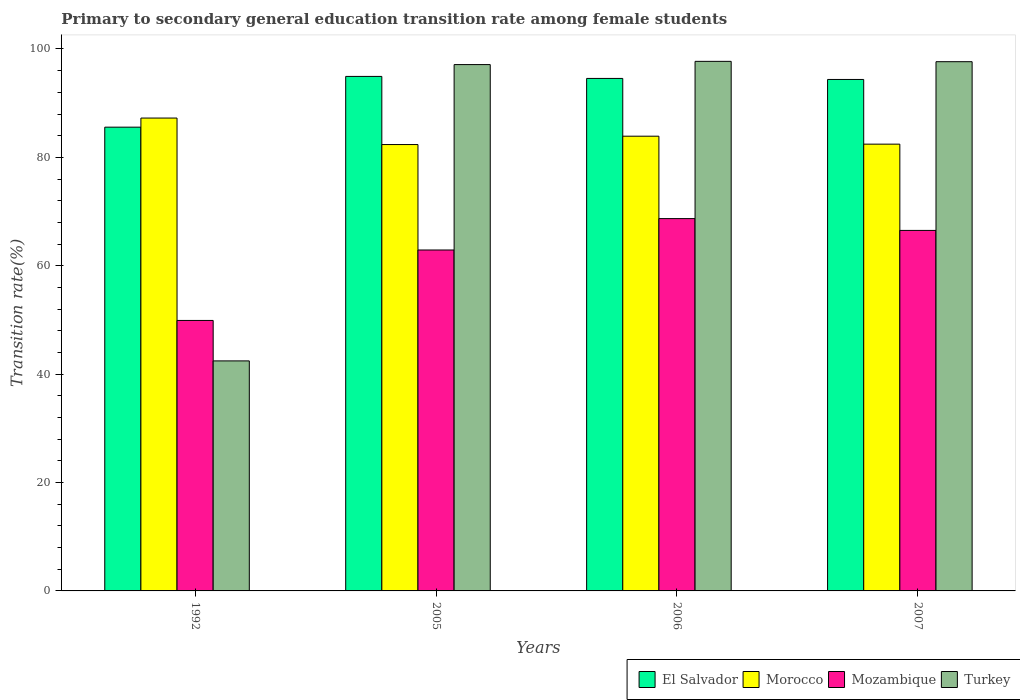How many different coloured bars are there?
Offer a very short reply. 4. How many groups of bars are there?
Offer a terse response. 4. Are the number of bars per tick equal to the number of legend labels?
Offer a terse response. Yes. How many bars are there on the 4th tick from the left?
Ensure brevity in your answer.  4. How many bars are there on the 1st tick from the right?
Your response must be concise. 4. What is the label of the 2nd group of bars from the left?
Provide a succinct answer. 2005. In how many cases, is the number of bars for a given year not equal to the number of legend labels?
Provide a short and direct response. 0. What is the transition rate in El Salvador in 2007?
Make the answer very short. 94.37. Across all years, what is the maximum transition rate in Mozambique?
Keep it short and to the point. 68.7. Across all years, what is the minimum transition rate in Mozambique?
Offer a terse response. 49.91. In which year was the transition rate in Mozambique maximum?
Offer a very short reply. 2006. What is the total transition rate in Turkey in the graph?
Make the answer very short. 334.93. What is the difference between the transition rate in El Salvador in 1992 and that in 2006?
Provide a succinct answer. -8.99. What is the difference between the transition rate in El Salvador in 2005 and the transition rate in Turkey in 2006?
Make the answer very short. -2.78. What is the average transition rate in Mozambique per year?
Provide a short and direct response. 62.01. In the year 1992, what is the difference between the transition rate in Mozambique and transition rate in El Salvador?
Make the answer very short. -35.66. What is the ratio of the transition rate in Morocco in 1992 to that in 2007?
Your response must be concise. 1.06. What is the difference between the highest and the second highest transition rate in Mozambique?
Provide a succinct answer. 2.18. What is the difference between the highest and the lowest transition rate in El Salvador?
Your answer should be very brief. 9.37. Is the sum of the transition rate in Turkey in 2005 and 2007 greater than the maximum transition rate in Morocco across all years?
Ensure brevity in your answer.  Yes. What does the 4th bar from the left in 2006 represents?
Provide a succinct answer. Turkey. What does the 2nd bar from the right in 2005 represents?
Offer a very short reply. Mozambique. How many bars are there?
Keep it short and to the point. 16. Are all the bars in the graph horizontal?
Provide a short and direct response. No. How many years are there in the graph?
Provide a short and direct response. 4. What is the difference between two consecutive major ticks on the Y-axis?
Provide a succinct answer. 20. Does the graph contain any zero values?
Make the answer very short. No. Where does the legend appear in the graph?
Provide a succinct answer. Bottom right. What is the title of the graph?
Provide a succinct answer. Primary to secondary general education transition rate among female students. What is the label or title of the X-axis?
Your response must be concise. Years. What is the label or title of the Y-axis?
Your response must be concise. Transition rate(%). What is the Transition rate(%) of El Salvador in 1992?
Ensure brevity in your answer.  85.57. What is the Transition rate(%) of Morocco in 1992?
Your answer should be compact. 87.25. What is the Transition rate(%) in Mozambique in 1992?
Give a very brief answer. 49.91. What is the Transition rate(%) in Turkey in 1992?
Make the answer very short. 42.44. What is the Transition rate(%) in El Salvador in 2005?
Give a very brief answer. 94.94. What is the Transition rate(%) of Morocco in 2005?
Your answer should be compact. 82.36. What is the Transition rate(%) in Mozambique in 2005?
Your response must be concise. 62.91. What is the Transition rate(%) in Turkey in 2005?
Offer a terse response. 97.12. What is the Transition rate(%) in El Salvador in 2006?
Offer a terse response. 94.56. What is the Transition rate(%) of Morocco in 2006?
Your response must be concise. 83.91. What is the Transition rate(%) in Mozambique in 2006?
Provide a succinct answer. 68.7. What is the Transition rate(%) in Turkey in 2006?
Your response must be concise. 97.72. What is the Transition rate(%) in El Salvador in 2007?
Your response must be concise. 94.37. What is the Transition rate(%) of Morocco in 2007?
Make the answer very short. 82.44. What is the Transition rate(%) in Mozambique in 2007?
Ensure brevity in your answer.  66.52. What is the Transition rate(%) in Turkey in 2007?
Your answer should be compact. 97.65. Across all years, what is the maximum Transition rate(%) in El Salvador?
Offer a terse response. 94.94. Across all years, what is the maximum Transition rate(%) in Morocco?
Ensure brevity in your answer.  87.25. Across all years, what is the maximum Transition rate(%) of Mozambique?
Provide a succinct answer. 68.7. Across all years, what is the maximum Transition rate(%) in Turkey?
Offer a terse response. 97.72. Across all years, what is the minimum Transition rate(%) of El Salvador?
Give a very brief answer. 85.57. Across all years, what is the minimum Transition rate(%) in Morocco?
Your response must be concise. 82.36. Across all years, what is the minimum Transition rate(%) of Mozambique?
Provide a short and direct response. 49.91. Across all years, what is the minimum Transition rate(%) of Turkey?
Keep it short and to the point. 42.44. What is the total Transition rate(%) in El Salvador in the graph?
Provide a succinct answer. 369.44. What is the total Transition rate(%) in Morocco in the graph?
Your response must be concise. 335.96. What is the total Transition rate(%) in Mozambique in the graph?
Offer a very short reply. 248.03. What is the total Transition rate(%) in Turkey in the graph?
Offer a terse response. 334.93. What is the difference between the Transition rate(%) in El Salvador in 1992 and that in 2005?
Provide a short and direct response. -9.37. What is the difference between the Transition rate(%) in Morocco in 1992 and that in 2005?
Offer a terse response. 4.89. What is the difference between the Transition rate(%) of Mozambique in 1992 and that in 2005?
Your response must be concise. -13. What is the difference between the Transition rate(%) in Turkey in 1992 and that in 2005?
Offer a terse response. -54.68. What is the difference between the Transition rate(%) of El Salvador in 1992 and that in 2006?
Your answer should be very brief. -8.99. What is the difference between the Transition rate(%) in Morocco in 1992 and that in 2006?
Make the answer very short. 3.35. What is the difference between the Transition rate(%) in Mozambique in 1992 and that in 2006?
Offer a terse response. -18.79. What is the difference between the Transition rate(%) in Turkey in 1992 and that in 2006?
Make the answer very short. -55.27. What is the difference between the Transition rate(%) of El Salvador in 1992 and that in 2007?
Your answer should be very brief. -8.8. What is the difference between the Transition rate(%) in Morocco in 1992 and that in 2007?
Offer a very short reply. 4.82. What is the difference between the Transition rate(%) in Mozambique in 1992 and that in 2007?
Offer a terse response. -16.61. What is the difference between the Transition rate(%) of Turkey in 1992 and that in 2007?
Your answer should be compact. -55.21. What is the difference between the Transition rate(%) in El Salvador in 2005 and that in 2006?
Make the answer very short. 0.37. What is the difference between the Transition rate(%) in Morocco in 2005 and that in 2006?
Ensure brevity in your answer.  -1.54. What is the difference between the Transition rate(%) of Mozambique in 2005 and that in 2006?
Offer a terse response. -5.79. What is the difference between the Transition rate(%) in Turkey in 2005 and that in 2006?
Provide a short and direct response. -0.6. What is the difference between the Transition rate(%) of El Salvador in 2005 and that in 2007?
Offer a terse response. 0.56. What is the difference between the Transition rate(%) in Morocco in 2005 and that in 2007?
Your response must be concise. -0.08. What is the difference between the Transition rate(%) in Mozambique in 2005 and that in 2007?
Keep it short and to the point. -3.61. What is the difference between the Transition rate(%) in Turkey in 2005 and that in 2007?
Ensure brevity in your answer.  -0.53. What is the difference between the Transition rate(%) of El Salvador in 2006 and that in 2007?
Provide a short and direct response. 0.19. What is the difference between the Transition rate(%) in Morocco in 2006 and that in 2007?
Ensure brevity in your answer.  1.47. What is the difference between the Transition rate(%) of Mozambique in 2006 and that in 2007?
Your answer should be compact. 2.18. What is the difference between the Transition rate(%) of Turkey in 2006 and that in 2007?
Give a very brief answer. 0.06. What is the difference between the Transition rate(%) in El Salvador in 1992 and the Transition rate(%) in Morocco in 2005?
Ensure brevity in your answer.  3.21. What is the difference between the Transition rate(%) in El Salvador in 1992 and the Transition rate(%) in Mozambique in 2005?
Ensure brevity in your answer.  22.66. What is the difference between the Transition rate(%) of El Salvador in 1992 and the Transition rate(%) of Turkey in 2005?
Ensure brevity in your answer.  -11.55. What is the difference between the Transition rate(%) of Morocco in 1992 and the Transition rate(%) of Mozambique in 2005?
Your answer should be very brief. 24.34. What is the difference between the Transition rate(%) of Morocco in 1992 and the Transition rate(%) of Turkey in 2005?
Your response must be concise. -9.87. What is the difference between the Transition rate(%) of Mozambique in 1992 and the Transition rate(%) of Turkey in 2005?
Provide a succinct answer. -47.21. What is the difference between the Transition rate(%) in El Salvador in 1992 and the Transition rate(%) in Morocco in 2006?
Keep it short and to the point. 1.66. What is the difference between the Transition rate(%) in El Salvador in 1992 and the Transition rate(%) in Mozambique in 2006?
Give a very brief answer. 16.87. What is the difference between the Transition rate(%) of El Salvador in 1992 and the Transition rate(%) of Turkey in 2006?
Keep it short and to the point. -12.14. What is the difference between the Transition rate(%) in Morocco in 1992 and the Transition rate(%) in Mozambique in 2006?
Provide a short and direct response. 18.55. What is the difference between the Transition rate(%) in Morocco in 1992 and the Transition rate(%) in Turkey in 2006?
Make the answer very short. -10.46. What is the difference between the Transition rate(%) of Mozambique in 1992 and the Transition rate(%) of Turkey in 2006?
Give a very brief answer. -47.81. What is the difference between the Transition rate(%) of El Salvador in 1992 and the Transition rate(%) of Morocco in 2007?
Offer a very short reply. 3.13. What is the difference between the Transition rate(%) of El Salvador in 1992 and the Transition rate(%) of Mozambique in 2007?
Keep it short and to the point. 19.05. What is the difference between the Transition rate(%) in El Salvador in 1992 and the Transition rate(%) in Turkey in 2007?
Offer a terse response. -12.08. What is the difference between the Transition rate(%) in Morocco in 1992 and the Transition rate(%) in Mozambique in 2007?
Ensure brevity in your answer.  20.73. What is the difference between the Transition rate(%) of Morocco in 1992 and the Transition rate(%) of Turkey in 2007?
Provide a succinct answer. -10.4. What is the difference between the Transition rate(%) of Mozambique in 1992 and the Transition rate(%) of Turkey in 2007?
Give a very brief answer. -47.74. What is the difference between the Transition rate(%) of El Salvador in 2005 and the Transition rate(%) of Morocco in 2006?
Make the answer very short. 11.03. What is the difference between the Transition rate(%) in El Salvador in 2005 and the Transition rate(%) in Mozambique in 2006?
Keep it short and to the point. 26.24. What is the difference between the Transition rate(%) in El Salvador in 2005 and the Transition rate(%) in Turkey in 2006?
Your answer should be very brief. -2.78. What is the difference between the Transition rate(%) in Morocco in 2005 and the Transition rate(%) in Mozambique in 2006?
Your answer should be very brief. 13.66. What is the difference between the Transition rate(%) of Morocco in 2005 and the Transition rate(%) of Turkey in 2006?
Your response must be concise. -15.35. What is the difference between the Transition rate(%) of Mozambique in 2005 and the Transition rate(%) of Turkey in 2006?
Ensure brevity in your answer.  -34.81. What is the difference between the Transition rate(%) in El Salvador in 2005 and the Transition rate(%) in Morocco in 2007?
Offer a terse response. 12.5. What is the difference between the Transition rate(%) of El Salvador in 2005 and the Transition rate(%) of Mozambique in 2007?
Offer a terse response. 28.42. What is the difference between the Transition rate(%) of El Salvador in 2005 and the Transition rate(%) of Turkey in 2007?
Provide a short and direct response. -2.72. What is the difference between the Transition rate(%) of Morocco in 2005 and the Transition rate(%) of Mozambique in 2007?
Your answer should be compact. 15.84. What is the difference between the Transition rate(%) in Morocco in 2005 and the Transition rate(%) in Turkey in 2007?
Provide a short and direct response. -15.29. What is the difference between the Transition rate(%) of Mozambique in 2005 and the Transition rate(%) of Turkey in 2007?
Your answer should be compact. -34.74. What is the difference between the Transition rate(%) of El Salvador in 2006 and the Transition rate(%) of Morocco in 2007?
Your answer should be compact. 12.13. What is the difference between the Transition rate(%) in El Salvador in 2006 and the Transition rate(%) in Mozambique in 2007?
Your answer should be compact. 28.04. What is the difference between the Transition rate(%) of El Salvador in 2006 and the Transition rate(%) of Turkey in 2007?
Your answer should be very brief. -3.09. What is the difference between the Transition rate(%) in Morocco in 2006 and the Transition rate(%) in Mozambique in 2007?
Provide a short and direct response. 17.39. What is the difference between the Transition rate(%) in Morocco in 2006 and the Transition rate(%) in Turkey in 2007?
Your response must be concise. -13.75. What is the difference between the Transition rate(%) of Mozambique in 2006 and the Transition rate(%) of Turkey in 2007?
Ensure brevity in your answer.  -28.95. What is the average Transition rate(%) of El Salvador per year?
Ensure brevity in your answer.  92.36. What is the average Transition rate(%) in Morocco per year?
Your response must be concise. 83.99. What is the average Transition rate(%) in Mozambique per year?
Your answer should be compact. 62.01. What is the average Transition rate(%) in Turkey per year?
Give a very brief answer. 83.73. In the year 1992, what is the difference between the Transition rate(%) in El Salvador and Transition rate(%) in Morocco?
Your response must be concise. -1.68. In the year 1992, what is the difference between the Transition rate(%) in El Salvador and Transition rate(%) in Mozambique?
Your response must be concise. 35.66. In the year 1992, what is the difference between the Transition rate(%) of El Salvador and Transition rate(%) of Turkey?
Your response must be concise. 43.13. In the year 1992, what is the difference between the Transition rate(%) of Morocco and Transition rate(%) of Mozambique?
Offer a terse response. 37.35. In the year 1992, what is the difference between the Transition rate(%) of Morocco and Transition rate(%) of Turkey?
Ensure brevity in your answer.  44.81. In the year 1992, what is the difference between the Transition rate(%) in Mozambique and Transition rate(%) in Turkey?
Your answer should be very brief. 7.46. In the year 2005, what is the difference between the Transition rate(%) of El Salvador and Transition rate(%) of Morocco?
Your answer should be compact. 12.57. In the year 2005, what is the difference between the Transition rate(%) in El Salvador and Transition rate(%) in Mozambique?
Provide a succinct answer. 32.03. In the year 2005, what is the difference between the Transition rate(%) in El Salvador and Transition rate(%) in Turkey?
Offer a very short reply. -2.18. In the year 2005, what is the difference between the Transition rate(%) of Morocco and Transition rate(%) of Mozambique?
Your response must be concise. 19.45. In the year 2005, what is the difference between the Transition rate(%) of Morocco and Transition rate(%) of Turkey?
Offer a terse response. -14.76. In the year 2005, what is the difference between the Transition rate(%) of Mozambique and Transition rate(%) of Turkey?
Offer a very short reply. -34.21. In the year 2006, what is the difference between the Transition rate(%) in El Salvador and Transition rate(%) in Morocco?
Give a very brief answer. 10.66. In the year 2006, what is the difference between the Transition rate(%) of El Salvador and Transition rate(%) of Mozambique?
Give a very brief answer. 25.86. In the year 2006, what is the difference between the Transition rate(%) in El Salvador and Transition rate(%) in Turkey?
Ensure brevity in your answer.  -3.15. In the year 2006, what is the difference between the Transition rate(%) in Morocco and Transition rate(%) in Mozambique?
Provide a short and direct response. 15.21. In the year 2006, what is the difference between the Transition rate(%) of Morocco and Transition rate(%) of Turkey?
Your answer should be very brief. -13.81. In the year 2006, what is the difference between the Transition rate(%) of Mozambique and Transition rate(%) of Turkey?
Your answer should be compact. -29.02. In the year 2007, what is the difference between the Transition rate(%) in El Salvador and Transition rate(%) in Morocco?
Ensure brevity in your answer.  11.93. In the year 2007, what is the difference between the Transition rate(%) in El Salvador and Transition rate(%) in Mozambique?
Make the answer very short. 27.85. In the year 2007, what is the difference between the Transition rate(%) of El Salvador and Transition rate(%) of Turkey?
Your response must be concise. -3.28. In the year 2007, what is the difference between the Transition rate(%) in Morocco and Transition rate(%) in Mozambique?
Provide a short and direct response. 15.92. In the year 2007, what is the difference between the Transition rate(%) of Morocco and Transition rate(%) of Turkey?
Provide a short and direct response. -15.21. In the year 2007, what is the difference between the Transition rate(%) of Mozambique and Transition rate(%) of Turkey?
Give a very brief answer. -31.13. What is the ratio of the Transition rate(%) of El Salvador in 1992 to that in 2005?
Make the answer very short. 0.9. What is the ratio of the Transition rate(%) in Morocco in 1992 to that in 2005?
Make the answer very short. 1.06. What is the ratio of the Transition rate(%) of Mozambique in 1992 to that in 2005?
Your answer should be very brief. 0.79. What is the ratio of the Transition rate(%) in Turkey in 1992 to that in 2005?
Offer a very short reply. 0.44. What is the ratio of the Transition rate(%) in El Salvador in 1992 to that in 2006?
Your answer should be compact. 0.9. What is the ratio of the Transition rate(%) in Morocco in 1992 to that in 2006?
Offer a very short reply. 1.04. What is the ratio of the Transition rate(%) in Mozambique in 1992 to that in 2006?
Make the answer very short. 0.73. What is the ratio of the Transition rate(%) of Turkey in 1992 to that in 2006?
Provide a succinct answer. 0.43. What is the ratio of the Transition rate(%) of El Salvador in 1992 to that in 2007?
Make the answer very short. 0.91. What is the ratio of the Transition rate(%) in Morocco in 1992 to that in 2007?
Make the answer very short. 1.06. What is the ratio of the Transition rate(%) of Mozambique in 1992 to that in 2007?
Your answer should be compact. 0.75. What is the ratio of the Transition rate(%) of Turkey in 1992 to that in 2007?
Make the answer very short. 0.43. What is the ratio of the Transition rate(%) in Morocco in 2005 to that in 2006?
Offer a terse response. 0.98. What is the ratio of the Transition rate(%) of Mozambique in 2005 to that in 2006?
Your answer should be compact. 0.92. What is the ratio of the Transition rate(%) of Turkey in 2005 to that in 2006?
Give a very brief answer. 0.99. What is the ratio of the Transition rate(%) of Mozambique in 2005 to that in 2007?
Your answer should be very brief. 0.95. What is the ratio of the Transition rate(%) in Turkey in 2005 to that in 2007?
Make the answer very short. 0.99. What is the ratio of the Transition rate(%) of El Salvador in 2006 to that in 2007?
Keep it short and to the point. 1. What is the ratio of the Transition rate(%) in Morocco in 2006 to that in 2007?
Offer a very short reply. 1.02. What is the ratio of the Transition rate(%) in Mozambique in 2006 to that in 2007?
Your response must be concise. 1.03. What is the ratio of the Transition rate(%) in Turkey in 2006 to that in 2007?
Make the answer very short. 1. What is the difference between the highest and the second highest Transition rate(%) of El Salvador?
Give a very brief answer. 0.37. What is the difference between the highest and the second highest Transition rate(%) in Morocco?
Your answer should be compact. 3.35. What is the difference between the highest and the second highest Transition rate(%) in Mozambique?
Your answer should be very brief. 2.18. What is the difference between the highest and the second highest Transition rate(%) in Turkey?
Offer a terse response. 0.06. What is the difference between the highest and the lowest Transition rate(%) of El Salvador?
Make the answer very short. 9.37. What is the difference between the highest and the lowest Transition rate(%) of Morocco?
Your answer should be compact. 4.89. What is the difference between the highest and the lowest Transition rate(%) in Mozambique?
Keep it short and to the point. 18.79. What is the difference between the highest and the lowest Transition rate(%) of Turkey?
Your answer should be compact. 55.27. 